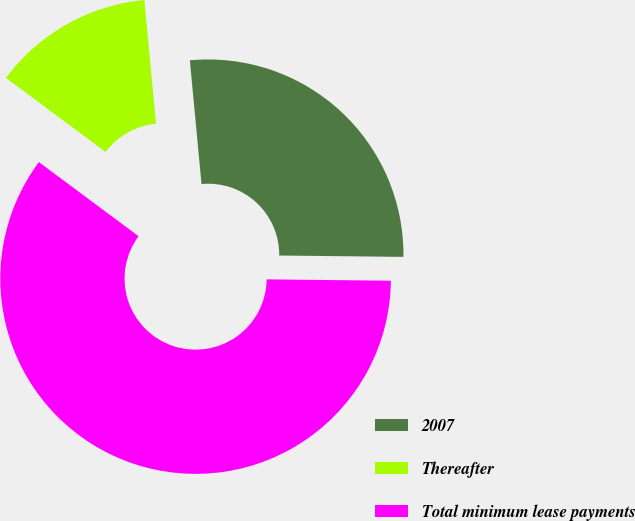Convert chart. <chart><loc_0><loc_0><loc_500><loc_500><pie_chart><fcel>2007<fcel>Thereafter<fcel>Total minimum lease payments<nl><fcel>26.67%<fcel>13.33%<fcel>60.0%<nl></chart> 